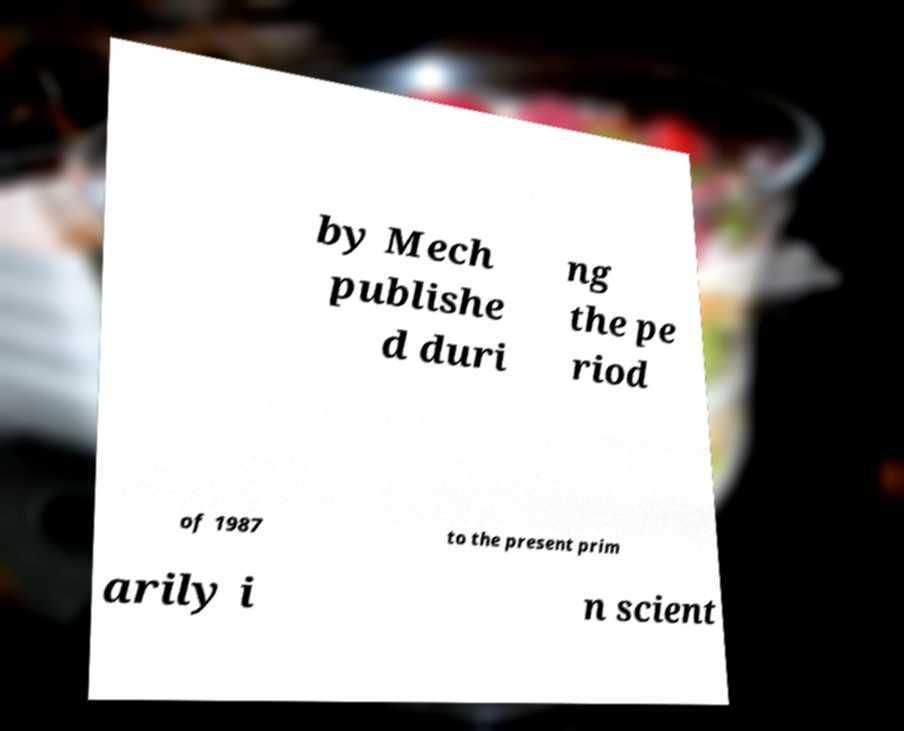For documentation purposes, I need the text within this image transcribed. Could you provide that? by Mech publishe d duri ng the pe riod of 1987 to the present prim arily i n scient 